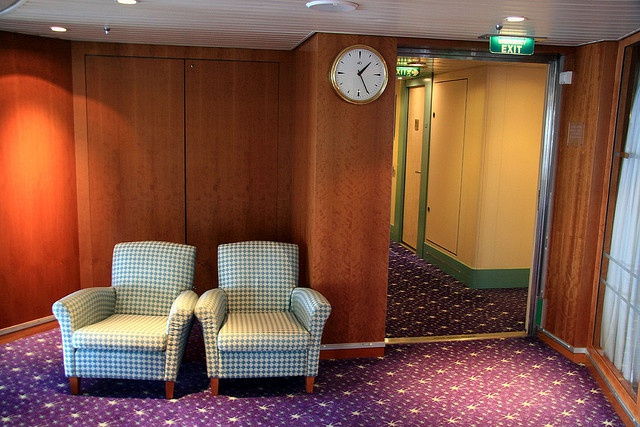Describe the objects in this image and their specific colors. I can see chair in gray, khaki, darkgray, and beige tones, chair in gray, darkgray, and tan tones, and clock in gray, darkgray, and maroon tones in this image. 